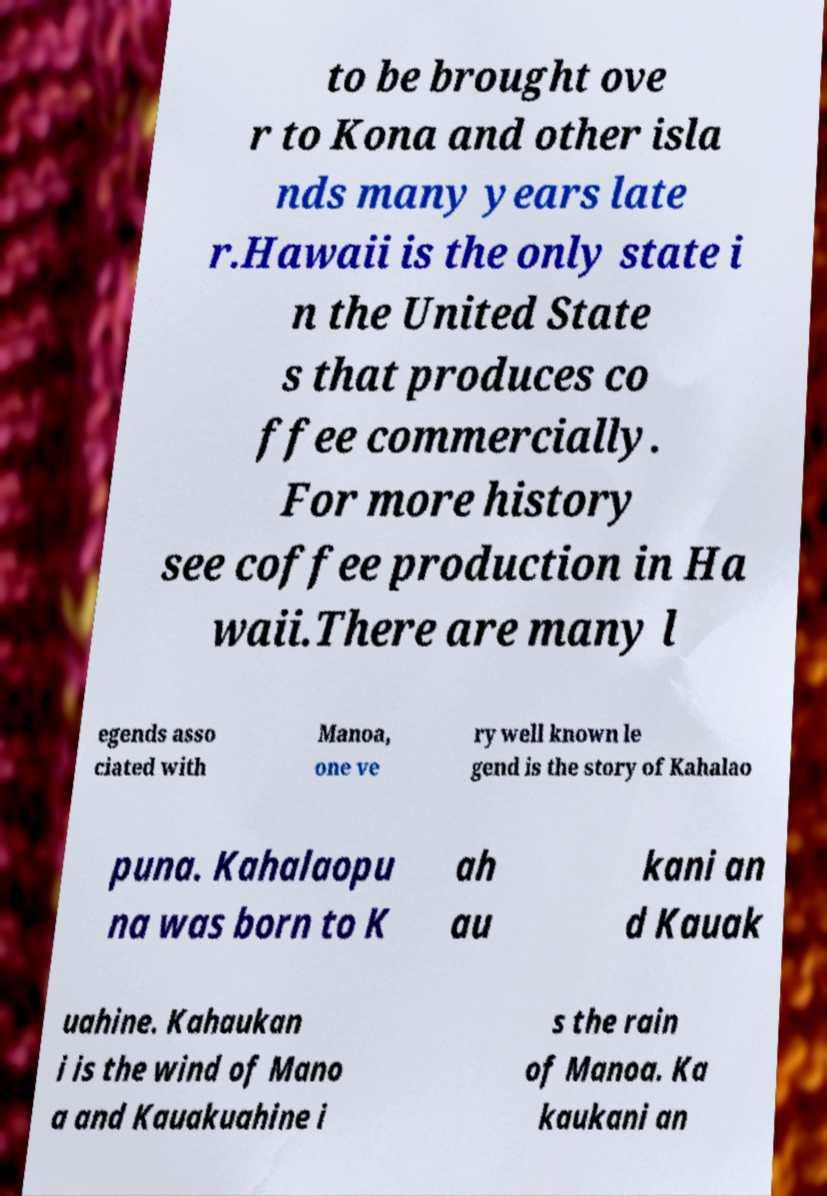Can you accurately transcribe the text from the provided image for me? to be brought ove r to Kona and other isla nds many years late r.Hawaii is the only state i n the United State s that produces co ffee commercially. For more history see coffee production in Ha waii.There are many l egends asso ciated with Manoa, one ve ry well known le gend is the story of Kahalao puna. Kahalaopu na was born to K ah au kani an d Kauak uahine. Kahaukan i is the wind of Mano a and Kauakuahine i s the rain of Manoa. Ka kaukani an 